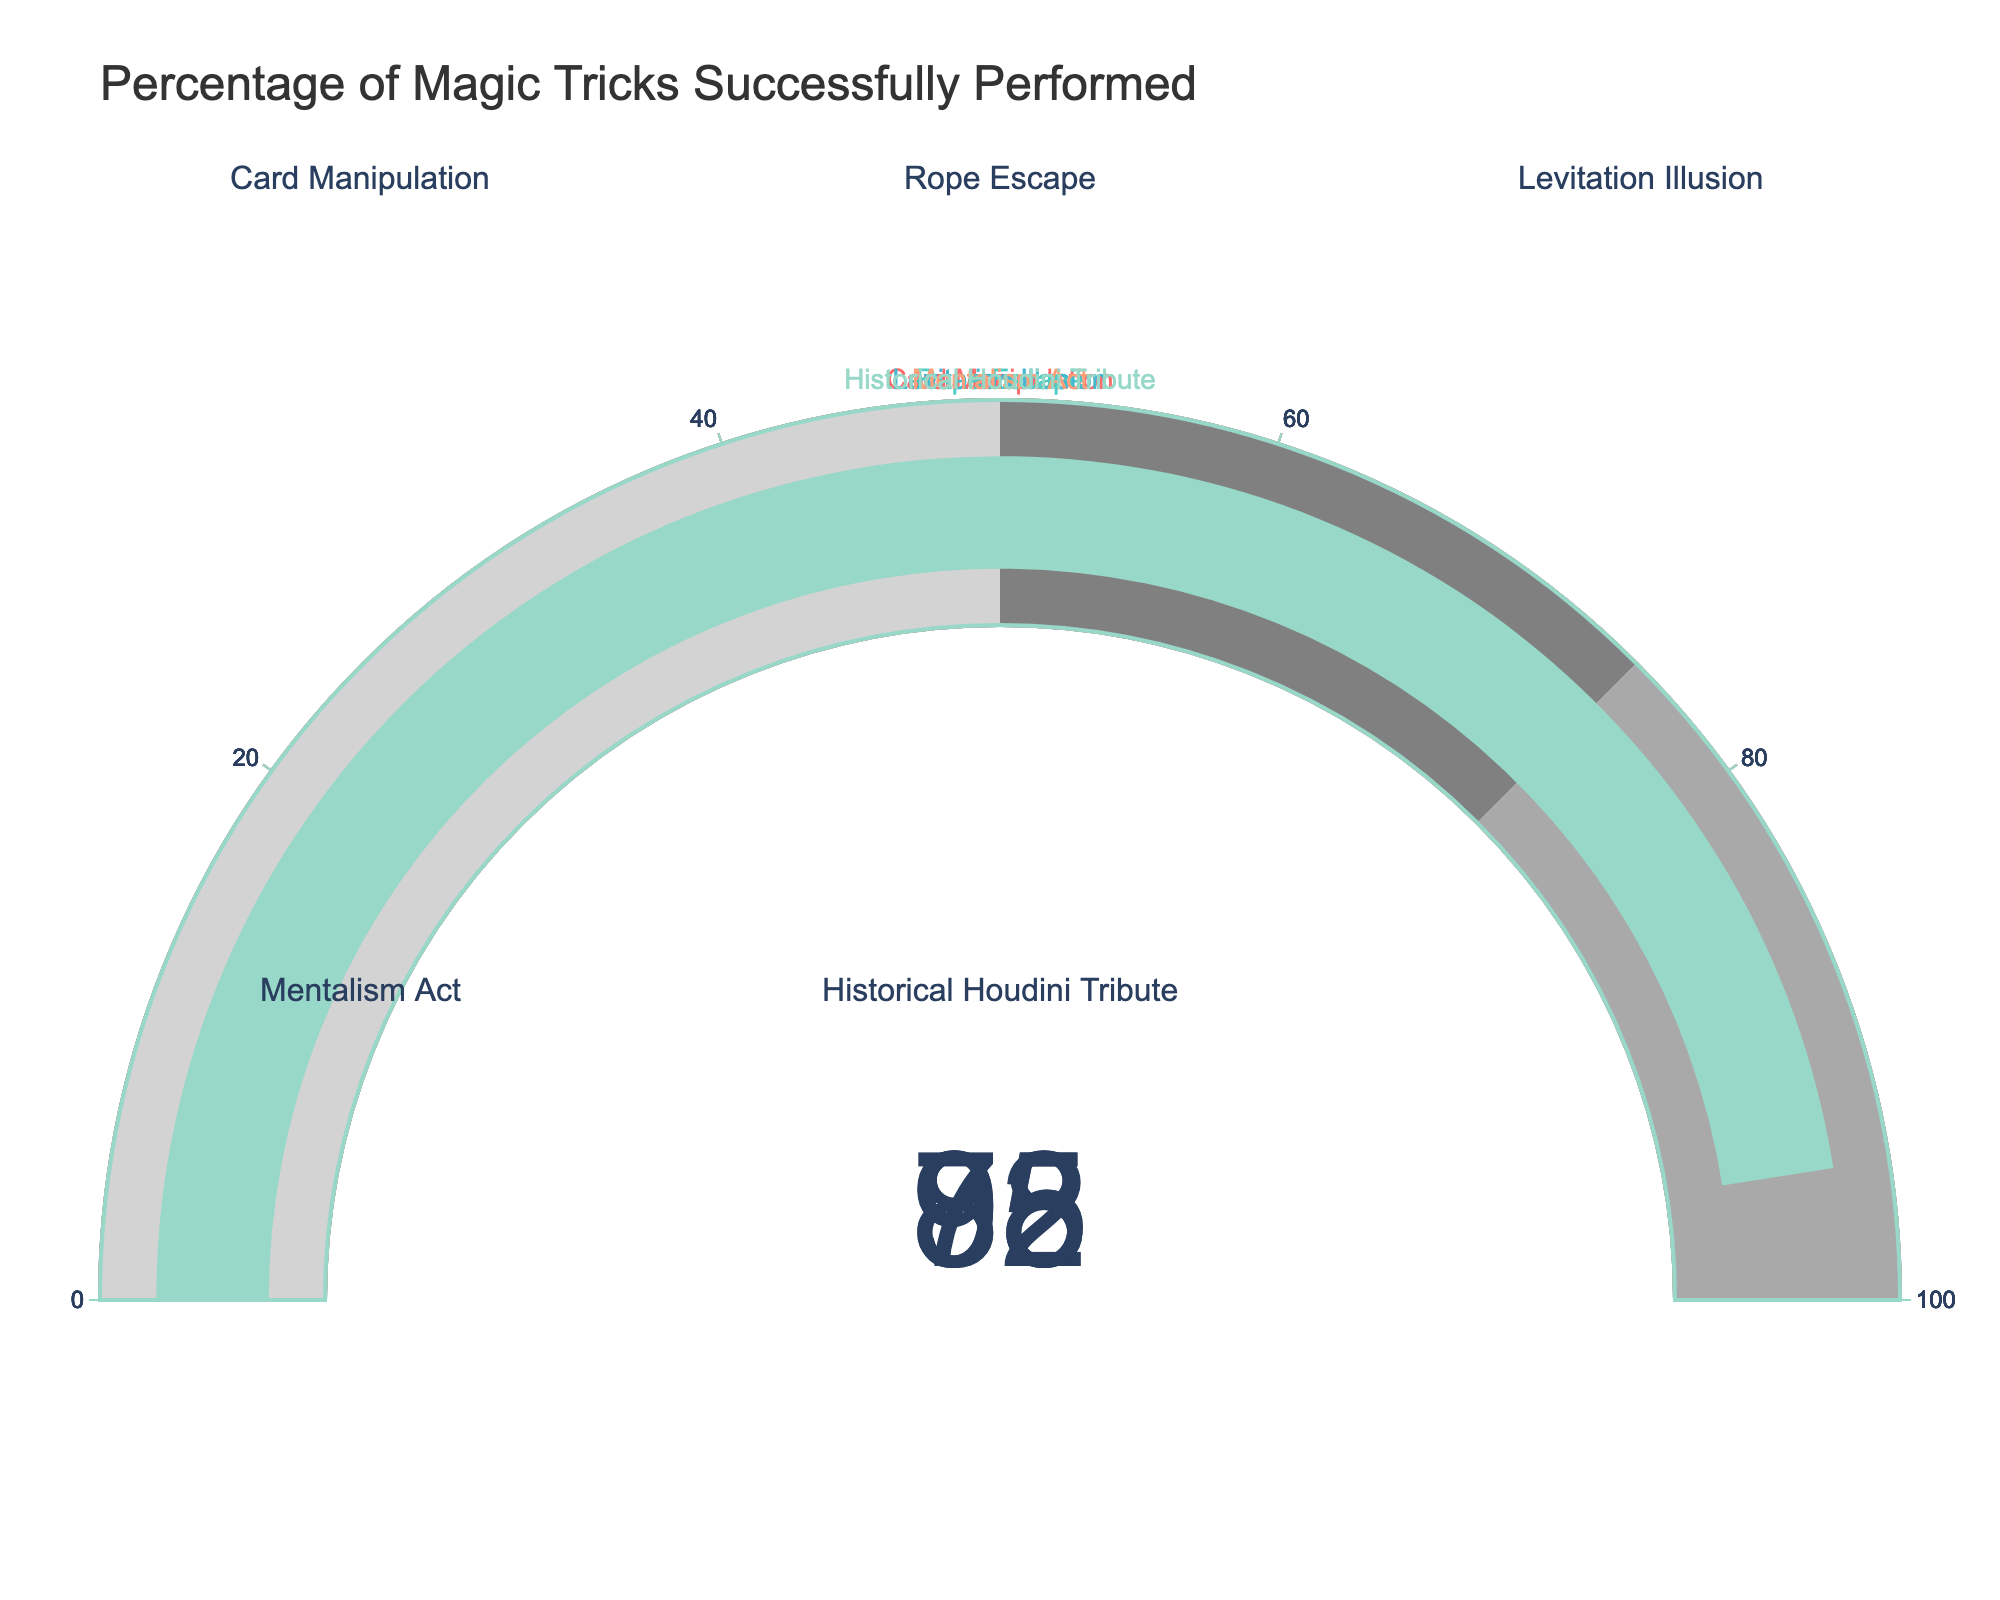What is the title of the figure? The title is prominently displayed at the top of the figure, it reads "Percentage of Magic Tricks Successfully Performed."
Answer: "Percentage of Magic Tricks Successfully Performed" What is the success rate for the Historical Houdini Tribute trick? The success rate for the Historical Houdini Tribute trick is shown on the gauge corresponding to this trick. The gauge points to 95.
Answer: 95 Which magic trick had the lowest success rate? By comparing all the gauges, the lowest success rate can be seen for the Levitation Illusion trick, which is at 78.
Answer: Levitation Illusion How many magic tricks are displayed in the figure? Counting all the individual gauges displayed in the figure, there are a total of 5 magic tricks represented.
Answer: 5 What is the average success rate of all the tricks performed? To find the average, sum all success rates and then divide by the total number of tricks: (85+92+78+88+95) / 5 = 87.6
Answer: 87.6 What's the difference in success rate between the Rope Escape and Mentalism Act tricks? Subtract the success rate of the Mentalism Act from the success rate of Rope Escape: 92 - 88 = 4
Answer: 4 Which trick's success rate is closest to 85? By looking at the gauges, Card Manipulation has a success rate of 85, which is the closest match.
Answer: Card Manipulation Are there any tricks with a success rate above 90? If yes, which ones? By examining the gauges, both Rope Escape (92) and Historical Houdini Tribute (95) have success rates above 90.
Answer: Rope Escape, Historical Houdini Tribute What is the median success rate of the magic tricks? To find the median, sort the success rates: [78, 85, 88, 92, 95]. The middle value is 88.
Answer: 88 What color is used for the gauge of the Levitation Illusion trick? The gauge for Levitation Illusion is shown in a distinct color, which is dark gray.
Answer: dark gray 